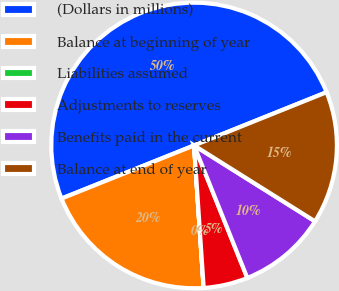Convert chart to OTSL. <chart><loc_0><loc_0><loc_500><loc_500><pie_chart><fcel>(Dollars in millions)<fcel>Balance at beginning of year<fcel>Liabilities assumed<fcel>Adjustments to reserves<fcel>Benefits paid in the current<fcel>Balance at end of year<nl><fcel>49.99%<fcel>20.0%<fcel>0.01%<fcel>5.01%<fcel>10.0%<fcel>15.0%<nl></chart> 